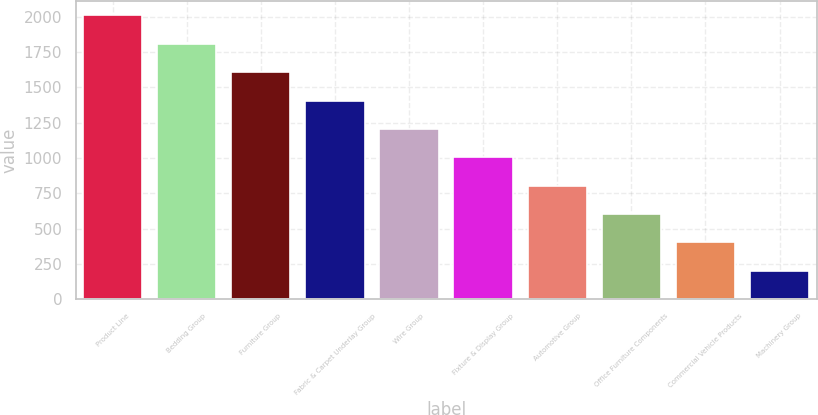<chart> <loc_0><loc_0><loc_500><loc_500><bar_chart><fcel>Product Line<fcel>Bedding Group<fcel>Furniture Group<fcel>Fabric & Carpet Underlay Group<fcel>Wire Group<fcel>Fixture & Display Group<fcel>Automotive Group<fcel>Office Furniture Components<fcel>Commercial Vehicle Products<fcel>Machinery Group<nl><fcel>2009<fcel>1808.3<fcel>1607.6<fcel>1406.9<fcel>1206.2<fcel>1005.5<fcel>804.8<fcel>604.1<fcel>403.4<fcel>202.7<nl></chart> 